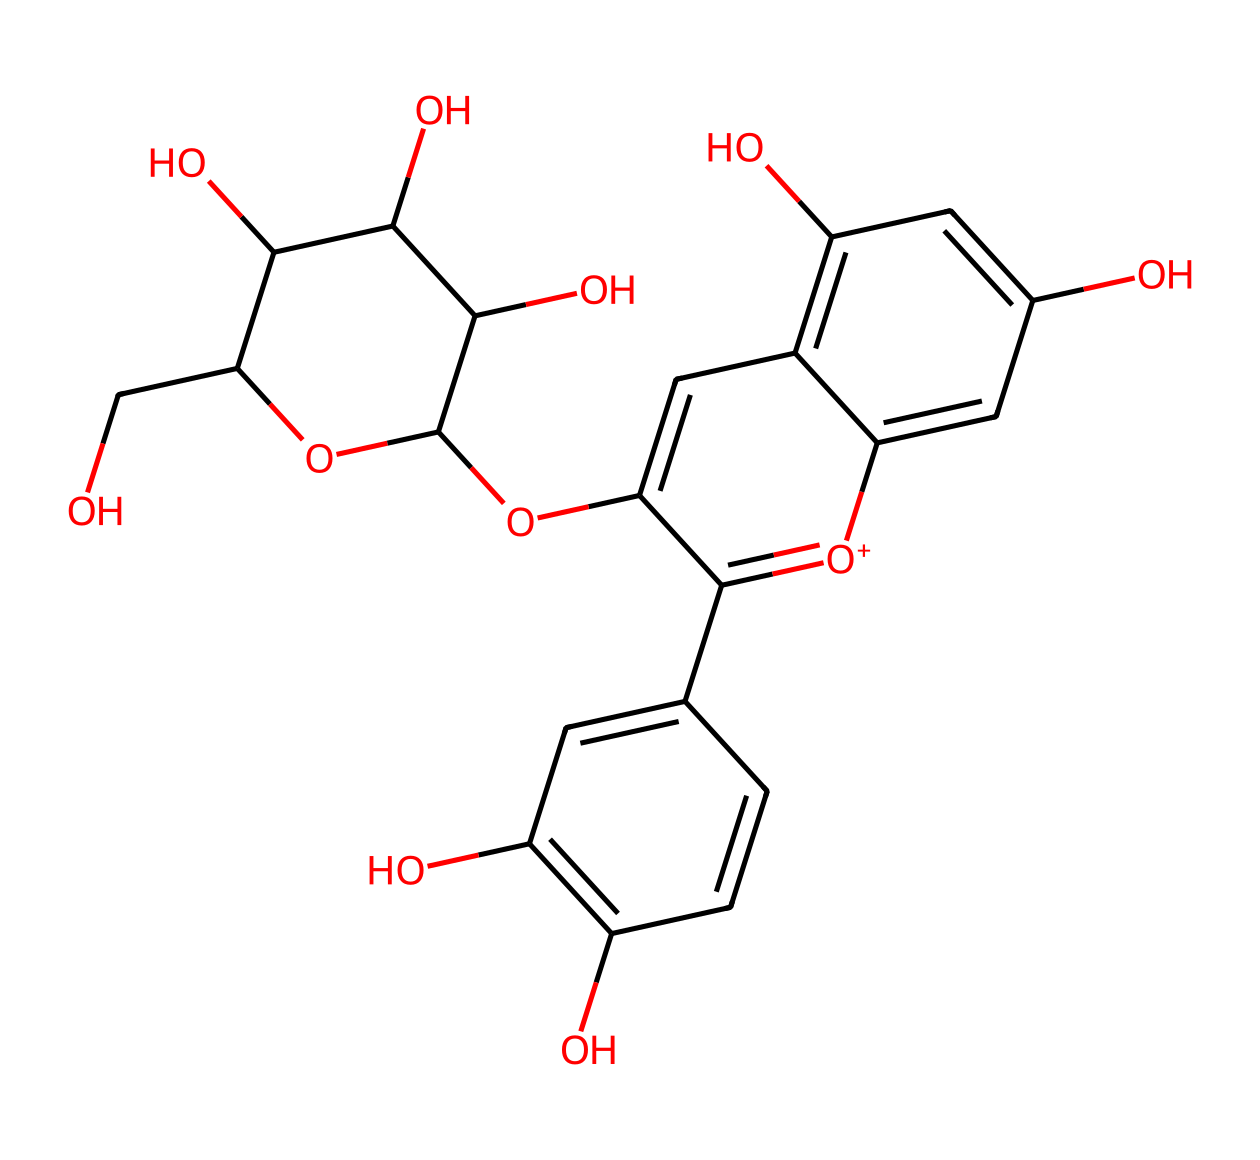What is the primary functional group present in this structure? The structure contains multiple hydroxyl (-OH) groups, which are characteristic of phenolic compounds. To identify the primary functional group, we look for the most significant feature across the molecule. In this structure, the extensive presence of hydroxyl groups indicates it is a phenolic compound.
Answer: hydroxyl How many rings are present in this chemical structure? Analyzing the structure shows that it contains three interconnected aromatic rings, often referred to as a polyphenolic structure. By counting the distinct ring regions in the SMILES representation, we can identify each of these aromatic components.
Answer: three What is the total number of carbon atoms in this compound? To determine the total number of carbon atoms, we can count each carbon represented in the structure. By assessing the SMILES notation, we identify that there are 21 carbon atoms in total.
Answer: twenty-one What type of chemical compound is represented by this structure? The presence of multiple hydroxyl groups attached to aromatic rings indicates this compound is a flavonoid, specifically an anthocyanin. The structural features specific to this class of compounds can be recognized based on their characteristic phenolic structures.
Answer: anthocyanin Which element is the most abundant in this chemical structure? By evaluating the atom count in the molecular structure, it is evident that carbon atoms are the most numerous relative to other atoms present. Through careful inspection of all elemental symbols, we conclude carbon is the predominant element.
Answer: carbon 